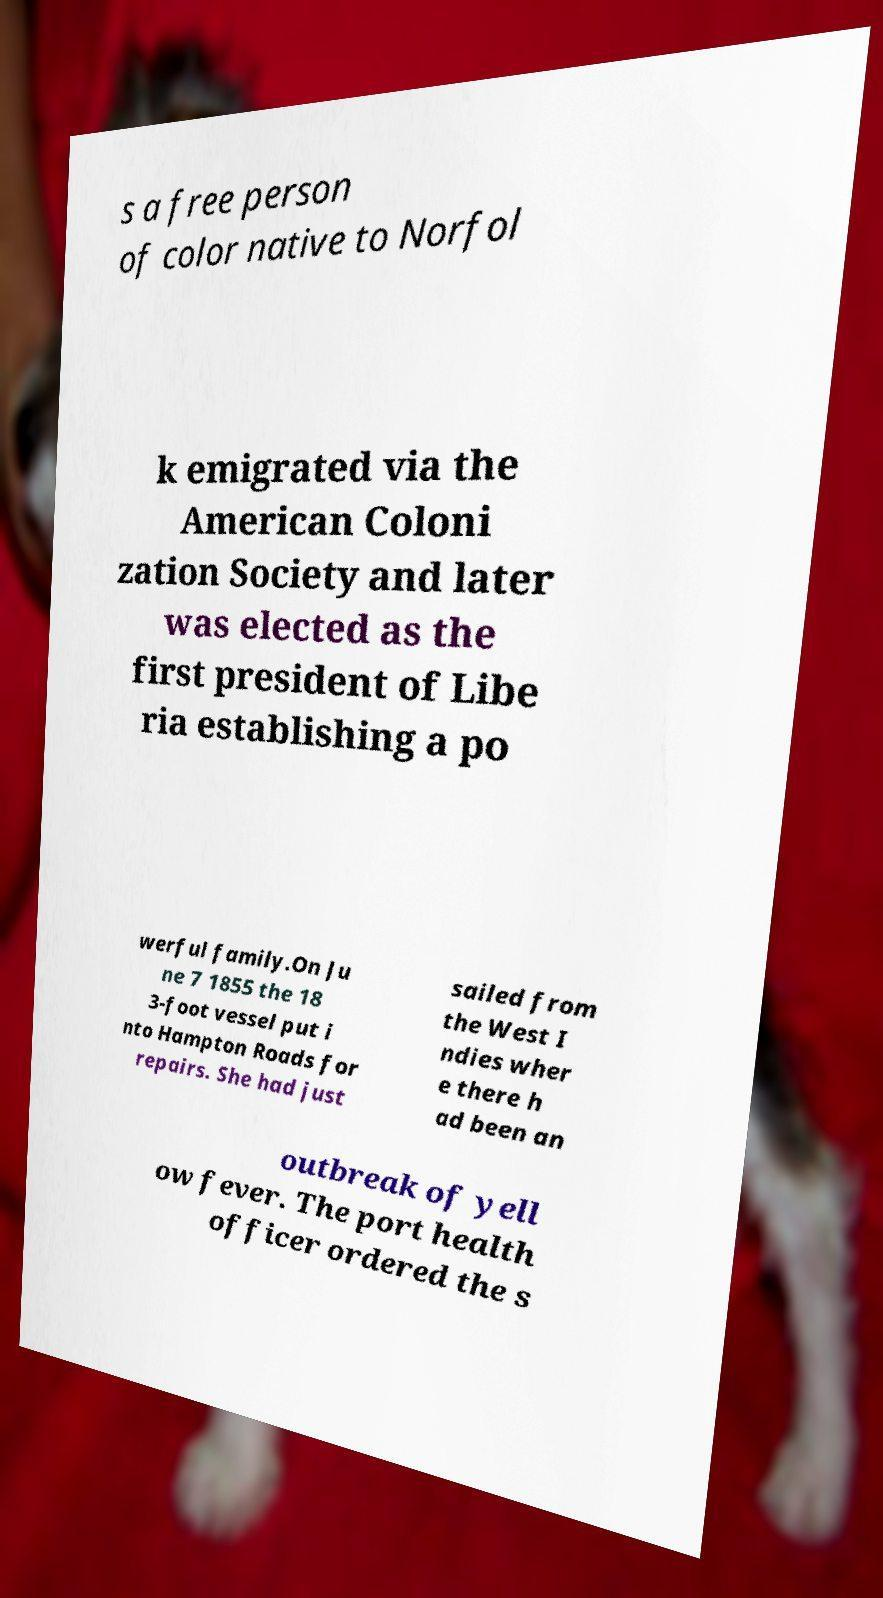Could you assist in decoding the text presented in this image and type it out clearly? s a free person of color native to Norfol k emigrated via the American Coloni zation Society and later was elected as the first president of Libe ria establishing a po werful family.On Ju ne 7 1855 the 18 3-foot vessel put i nto Hampton Roads for repairs. She had just sailed from the West I ndies wher e there h ad been an outbreak of yell ow fever. The port health officer ordered the s 